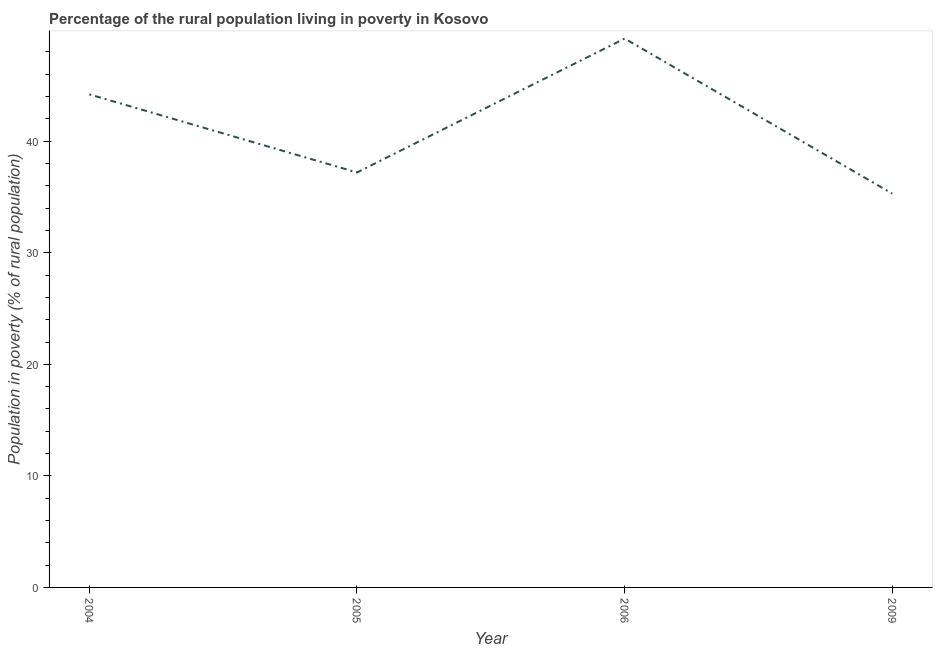What is the percentage of rural population living below poverty line in 2005?
Provide a short and direct response. 37.2. Across all years, what is the maximum percentage of rural population living below poverty line?
Your response must be concise. 49.2. Across all years, what is the minimum percentage of rural population living below poverty line?
Your response must be concise. 35.3. What is the sum of the percentage of rural population living below poverty line?
Offer a very short reply. 165.9. What is the difference between the percentage of rural population living below poverty line in 2006 and 2009?
Make the answer very short. 13.9. What is the average percentage of rural population living below poverty line per year?
Keep it short and to the point. 41.48. What is the median percentage of rural population living below poverty line?
Your response must be concise. 40.7. In how many years, is the percentage of rural population living below poverty line greater than 44 %?
Your answer should be very brief. 2. What is the ratio of the percentage of rural population living below poverty line in 2004 to that in 2009?
Offer a terse response. 1.25. Is the percentage of rural population living below poverty line in 2004 less than that in 2006?
Your answer should be very brief. Yes. Is the difference between the percentage of rural population living below poverty line in 2004 and 2005 greater than the difference between any two years?
Ensure brevity in your answer.  No. What is the difference between the highest and the second highest percentage of rural population living below poverty line?
Make the answer very short. 5. Is the sum of the percentage of rural population living below poverty line in 2006 and 2009 greater than the maximum percentage of rural population living below poverty line across all years?
Your answer should be very brief. Yes. What is the difference between the highest and the lowest percentage of rural population living below poverty line?
Offer a very short reply. 13.9. In how many years, is the percentage of rural population living below poverty line greater than the average percentage of rural population living below poverty line taken over all years?
Provide a short and direct response. 2. Does the percentage of rural population living below poverty line monotonically increase over the years?
Provide a short and direct response. No. How many lines are there?
Ensure brevity in your answer.  1. Does the graph contain any zero values?
Your response must be concise. No. Does the graph contain grids?
Offer a very short reply. No. What is the title of the graph?
Your answer should be very brief. Percentage of the rural population living in poverty in Kosovo. What is the label or title of the X-axis?
Give a very brief answer. Year. What is the label or title of the Y-axis?
Provide a short and direct response. Population in poverty (% of rural population). What is the Population in poverty (% of rural population) in 2004?
Provide a succinct answer. 44.2. What is the Population in poverty (% of rural population) of 2005?
Keep it short and to the point. 37.2. What is the Population in poverty (% of rural population) of 2006?
Make the answer very short. 49.2. What is the Population in poverty (% of rural population) in 2009?
Keep it short and to the point. 35.3. What is the difference between the Population in poverty (% of rural population) in 2004 and 2005?
Your response must be concise. 7. What is the difference between the Population in poverty (% of rural population) in 2004 and 2006?
Provide a succinct answer. -5. What is the difference between the Population in poverty (% of rural population) in 2005 and 2006?
Ensure brevity in your answer.  -12. What is the difference between the Population in poverty (% of rural population) in 2005 and 2009?
Provide a short and direct response. 1.9. What is the ratio of the Population in poverty (% of rural population) in 2004 to that in 2005?
Provide a short and direct response. 1.19. What is the ratio of the Population in poverty (% of rural population) in 2004 to that in 2006?
Your answer should be compact. 0.9. What is the ratio of the Population in poverty (% of rural population) in 2004 to that in 2009?
Your answer should be compact. 1.25. What is the ratio of the Population in poverty (% of rural population) in 2005 to that in 2006?
Your response must be concise. 0.76. What is the ratio of the Population in poverty (% of rural population) in 2005 to that in 2009?
Your answer should be compact. 1.05. What is the ratio of the Population in poverty (% of rural population) in 2006 to that in 2009?
Provide a short and direct response. 1.39. 